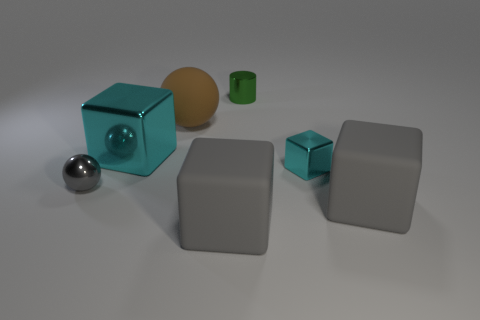What number of small shiny cubes are the same color as the cylinder?
Offer a very short reply. 0. Does the small cyan object have the same shape as the big brown thing?
Your response must be concise. No. Are there any other things that are the same size as the green shiny cylinder?
Your response must be concise. Yes. The brown rubber object that is the same shape as the tiny gray metallic thing is what size?
Make the answer very short. Large. Is the number of gray metal objects to the left of the tiny gray metallic sphere greater than the number of small green cylinders that are right of the small cyan block?
Ensure brevity in your answer.  No. Are the cylinder and the cyan thing that is to the left of the tiny cyan cube made of the same material?
Your answer should be very brief. Yes. Is there any other thing that has the same shape as the big brown object?
Offer a very short reply. Yes. There is a big rubber object that is both to the left of the small green metal cylinder and in front of the tiny metallic block; what color is it?
Your answer should be compact. Gray. The cyan thing that is right of the big brown matte ball has what shape?
Your answer should be very brief. Cube. There is a gray object in front of the big rubber block to the right of the small metallic thing that is right of the tiny green cylinder; what size is it?
Provide a succinct answer. Large. 